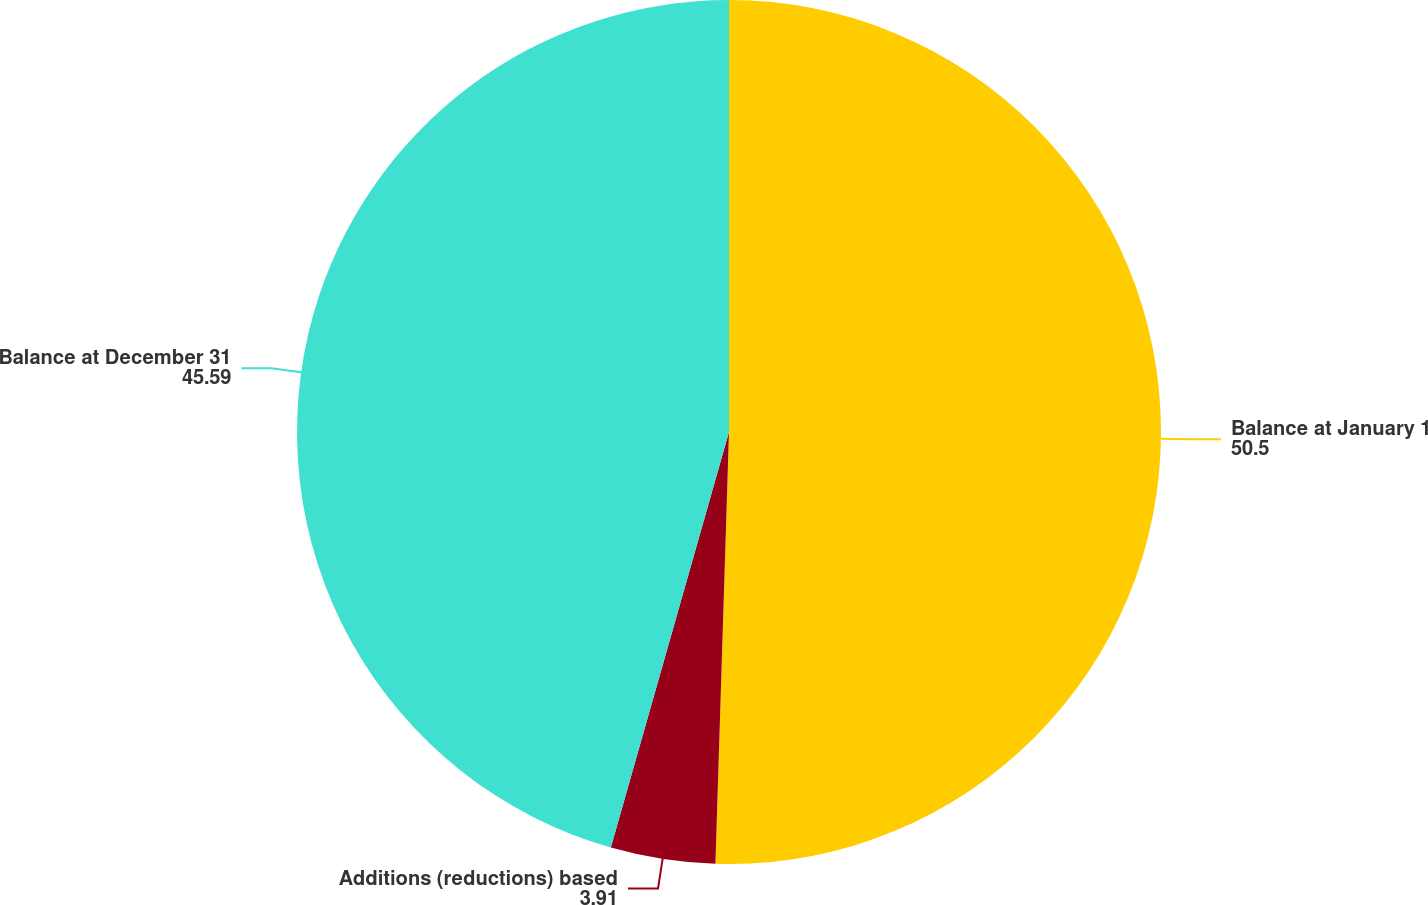<chart> <loc_0><loc_0><loc_500><loc_500><pie_chart><fcel>Balance at January 1<fcel>Additions (reductions) based<fcel>Balance at December 31<nl><fcel>50.5%<fcel>3.91%<fcel>45.59%<nl></chart> 